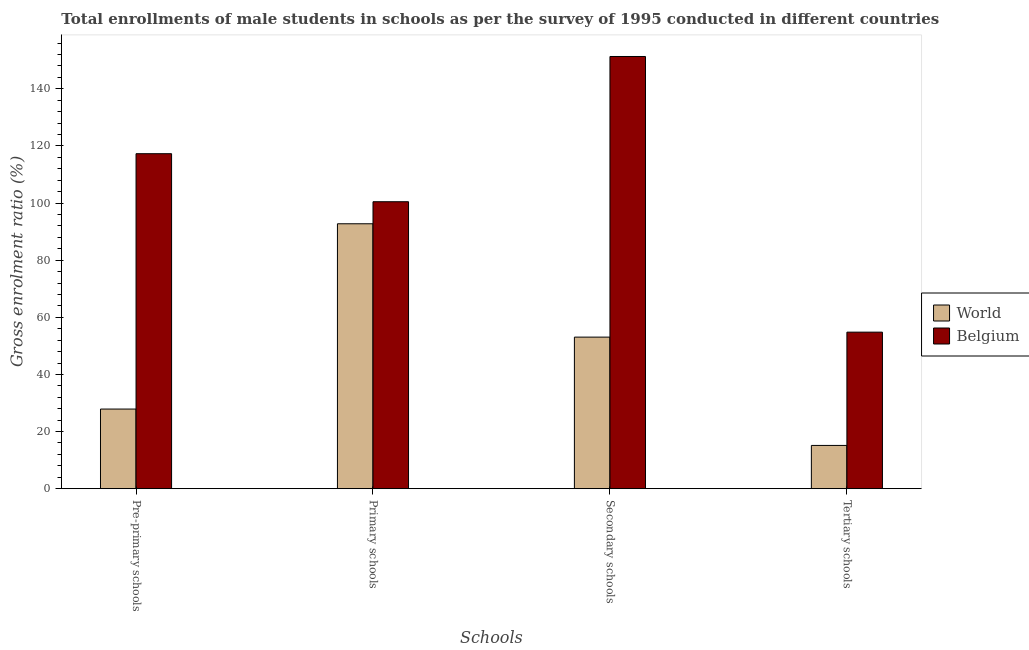How many different coloured bars are there?
Give a very brief answer. 2. How many groups of bars are there?
Offer a terse response. 4. Are the number of bars on each tick of the X-axis equal?
Offer a terse response. Yes. How many bars are there on the 1st tick from the left?
Provide a short and direct response. 2. What is the label of the 1st group of bars from the left?
Provide a succinct answer. Pre-primary schools. What is the gross enrolment ratio(male) in pre-primary schools in Belgium?
Your answer should be compact. 117.29. Across all countries, what is the maximum gross enrolment ratio(male) in primary schools?
Provide a succinct answer. 100.47. Across all countries, what is the minimum gross enrolment ratio(male) in primary schools?
Keep it short and to the point. 92.76. What is the total gross enrolment ratio(male) in secondary schools in the graph?
Provide a short and direct response. 204.4. What is the difference between the gross enrolment ratio(male) in pre-primary schools in World and that in Belgium?
Your response must be concise. -89.41. What is the difference between the gross enrolment ratio(male) in tertiary schools in Belgium and the gross enrolment ratio(male) in primary schools in World?
Your response must be concise. -37.95. What is the average gross enrolment ratio(male) in tertiary schools per country?
Keep it short and to the point. 34.97. What is the difference between the gross enrolment ratio(male) in pre-primary schools and gross enrolment ratio(male) in primary schools in World?
Keep it short and to the point. -64.88. In how many countries, is the gross enrolment ratio(male) in tertiary schools greater than 4 %?
Your answer should be compact. 2. What is the ratio of the gross enrolment ratio(male) in tertiary schools in World to that in Belgium?
Offer a very short reply. 0.28. Is the gross enrolment ratio(male) in pre-primary schools in World less than that in Belgium?
Offer a terse response. Yes. What is the difference between the highest and the second highest gross enrolment ratio(male) in tertiary schools?
Provide a short and direct response. 39.66. What is the difference between the highest and the lowest gross enrolment ratio(male) in pre-primary schools?
Ensure brevity in your answer.  89.41. Is the sum of the gross enrolment ratio(male) in tertiary schools in Belgium and World greater than the maximum gross enrolment ratio(male) in primary schools across all countries?
Provide a succinct answer. No. Is it the case that in every country, the sum of the gross enrolment ratio(male) in pre-primary schools and gross enrolment ratio(male) in secondary schools is greater than the sum of gross enrolment ratio(male) in primary schools and gross enrolment ratio(male) in tertiary schools?
Provide a succinct answer. No. Is it the case that in every country, the sum of the gross enrolment ratio(male) in pre-primary schools and gross enrolment ratio(male) in primary schools is greater than the gross enrolment ratio(male) in secondary schools?
Your response must be concise. Yes. Are all the bars in the graph horizontal?
Your response must be concise. No. How many countries are there in the graph?
Offer a very short reply. 2. Are the values on the major ticks of Y-axis written in scientific E-notation?
Give a very brief answer. No. Does the graph contain any zero values?
Offer a very short reply. No. How many legend labels are there?
Make the answer very short. 2. How are the legend labels stacked?
Make the answer very short. Vertical. What is the title of the graph?
Offer a terse response. Total enrollments of male students in schools as per the survey of 1995 conducted in different countries. Does "Bangladesh" appear as one of the legend labels in the graph?
Offer a terse response. No. What is the label or title of the X-axis?
Your response must be concise. Schools. What is the Gross enrolment ratio (%) in World in Pre-primary schools?
Your answer should be compact. 27.88. What is the Gross enrolment ratio (%) of Belgium in Pre-primary schools?
Offer a very short reply. 117.29. What is the Gross enrolment ratio (%) in World in Primary schools?
Offer a terse response. 92.76. What is the Gross enrolment ratio (%) in Belgium in Primary schools?
Make the answer very short. 100.47. What is the Gross enrolment ratio (%) of World in Secondary schools?
Your answer should be compact. 53.07. What is the Gross enrolment ratio (%) in Belgium in Secondary schools?
Offer a terse response. 151.33. What is the Gross enrolment ratio (%) in World in Tertiary schools?
Make the answer very short. 15.14. What is the Gross enrolment ratio (%) in Belgium in Tertiary schools?
Offer a very short reply. 54.8. Across all Schools, what is the maximum Gross enrolment ratio (%) of World?
Provide a succinct answer. 92.76. Across all Schools, what is the maximum Gross enrolment ratio (%) of Belgium?
Make the answer very short. 151.33. Across all Schools, what is the minimum Gross enrolment ratio (%) of World?
Provide a succinct answer. 15.14. Across all Schools, what is the minimum Gross enrolment ratio (%) in Belgium?
Offer a terse response. 54.8. What is the total Gross enrolment ratio (%) of World in the graph?
Your answer should be very brief. 188.84. What is the total Gross enrolment ratio (%) of Belgium in the graph?
Ensure brevity in your answer.  423.89. What is the difference between the Gross enrolment ratio (%) in World in Pre-primary schools and that in Primary schools?
Provide a short and direct response. -64.88. What is the difference between the Gross enrolment ratio (%) in Belgium in Pre-primary schools and that in Primary schools?
Your answer should be compact. 16.82. What is the difference between the Gross enrolment ratio (%) of World in Pre-primary schools and that in Secondary schools?
Make the answer very short. -25.19. What is the difference between the Gross enrolment ratio (%) of Belgium in Pre-primary schools and that in Secondary schools?
Your answer should be compact. -34.04. What is the difference between the Gross enrolment ratio (%) in World in Pre-primary schools and that in Tertiary schools?
Give a very brief answer. 12.74. What is the difference between the Gross enrolment ratio (%) of Belgium in Pre-primary schools and that in Tertiary schools?
Provide a succinct answer. 62.48. What is the difference between the Gross enrolment ratio (%) in World in Primary schools and that in Secondary schools?
Give a very brief answer. 39.69. What is the difference between the Gross enrolment ratio (%) of Belgium in Primary schools and that in Secondary schools?
Keep it short and to the point. -50.86. What is the difference between the Gross enrolment ratio (%) of World in Primary schools and that in Tertiary schools?
Your answer should be very brief. 77.61. What is the difference between the Gross enrolment ratio (%) of Belgium in Primary schools and that in Tertiary schools?
Your answer should be compact. 45.67. What is the difference between the Gross enrolment ratio (%) of World in Secondary schools and that in Tertiary schools?
Make the answer very short. 37.93. What is the difference between the Gross enrolment ratio (%) of Belgium in Secondary schools and that in Tertiary schools?
Keep it short and to the point. 96.52. What is the difference between the Gross enrolment ratio (%) in World in Pre-primary schools and the Gross enrolment ratio (%) in Belgium in Primary schools?
Make the answer very short. -72.59. What is the difference between the Gross enrolment ratio (%) of World in Pre-primary schools and the Gross enrolment ratio (%) of Belgium in Secondary schools?
Offer a very short reply. -123.45. What is the difference between the Gross enrolment ratio (%) of World in Pre-primary schools and the Gross enrolment ratio (%) of Belgium in Tertiary schools?
Make the answer very short. -26.93. What is the difference between the Gross enrolment ratio (%) of World in Primary schools and the Gross enrolment ratio (%) of Belgium in Secondary schools?
Offer a very short reply. -58.57. What is the difference between the Gross enrolment ratio (%) in World in Primary schools and the Gross enrolment ratio (%) in Belgium in Tertiary schools?
Make the answer very short. 37.95. What is the difference between the Gross enrolment ratio (%) of World in Secondary schools and the Gross enrolment ratio (%) of Belgium in Tertiary schools?
Provide a succinct answer. -1.74. What is the average Gross enrolment ratio (%) of World per Schools?
Your response must be concise. 47.21. What is the average Gross enrolment ratio (%) in Belgium per Schools?
Your response must be concise. 105.97. What is the difference between the Gross enrolment ratio (%) in World and Gross enrolment ratio (%) in Belgium in Pre-primary schools?
Your answer should be very brief. -89.41. What is the difference between the Gross enrolment ratio (%) in World and Gross enrolment ratio (%) in Belgium in Primary schools?
Your answer should be compact. -7.72. What is the difference between the Gross enrolment ratio (%) of World and Gross enrolment ratio (%) of Belgium in Secondary schools?
Make the answer very short. -98.26. What is the difference between the Gross enrolment ratio (%) in World and Gross enrolment ratio (%) in Belgium in Tertiary schools?
Your answer should be compact. -39.66. What is the ratio of the Gross enrolment ratio (%) of World in Pre-primary schools to that in Primary schools?
Your answer should be very brief. 0.3. What is the ratio of the Gross enrolment ratio (%) in Belgium in Pre-primary schools to that in Primary schools?
Your answer should be compact. 1.17. What is the ratio of the Gross enrolment ratio (%) in World in Pre-primary schools to that in Secondary schools?
Provide a short and direct response. 0.53. What is the ratio of the Gross enrolment ratio (%) of Belgium in Pre-primary schools to that in Secondary schools?
Keep it short and to the point. 0.78. What is the ratio of the Gross enrolment ratio (%) in World in Pre-primary schools to that in Tertiary schools?
Ensure brevity in your answer.  1.84. What is the ratio of the Gross enrolment ratio (%) of Belgium in Pre-primary schools to that in Tertiary schools?
Keep it short and to the point. 2.14. What is the ratio of the Gross enrolment ratio (%) in World in Primary schools to that in Secondary schools?
Give a very brief answer. 1.75. What is the ratio of the Gross enrolment ratio (%) of Belgium in Primary schools to that in Secondary schools?
Your answer should be compact. 0.66. What is the ratio of the Gross enrolment ratio (%) of World in Primary schools to that in Tertiary schools?
Ensure brevity in your answer.  6.13. What is the ratio of the Gross enrolment ratio (%) of Belgium in Primary schools to that in Tertiary schools?
Your response must be concise. 1.83. What is the ratio of the Gross enrolment ratio (%) in World in Secondary schools to that in Tertiary schools?
Your response must be concise. 3.5. What is the ratio of the Gross enrolment ratio (%) in Belgium in Secondary schools to that in Tertiary schools?
Make the answer very short. 2.76. What is the difference between the highest and the second highest Gross enrolment ratio (%) of World?
Ensure brevity in your answer.  39.69. What is the difference between the highest and the second highest Gross enrolment ratio (%) in Belgium?
Ensure brevity in your answer.  34.04. What is the difference between the highest and the lowest Gross enrolment ratio (%) of World?
Your answer should be very brief. 77.61. What is the difference between the highest and the lowest Gross enrolment ratio (%) in Belgium?
Give a very brief answer. 96.52. 